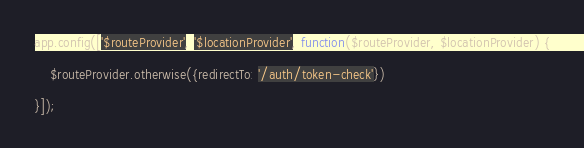Convert code to text. <code><loc_0><loc_0><loc_500><loc_500><_JavaScript_>app.config(['$routeProvider', '$locationProvider', function($routeProvider, $locationProvider) {

    $routeProvider.otherwise({redirectTo: '/auth/token-check'})

}]);
</code> 